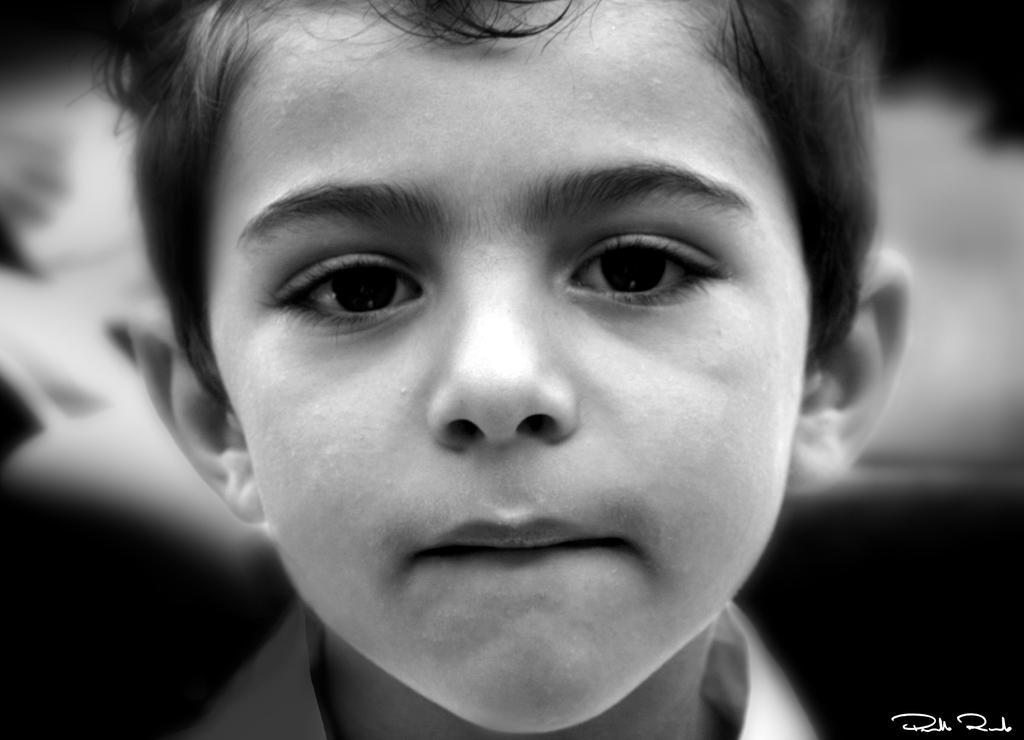In one or two sentences, can you explain what this image depicts? This picture shows a boy and we see a watermark at the bottom right corner. 